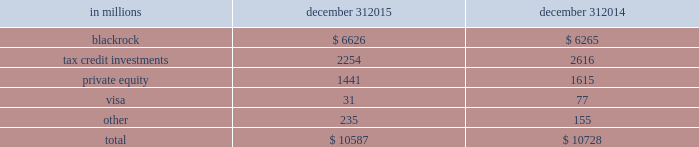An institution rated single-a by the credit rating agencies .
Given the illiquid nature of many of these types of investments , it can be a challenge to determine their fair values .
See note 7 fair value in the notes to consolidated financial statements in item 8 of this report for additional information .
Various pnc business units manage our equity and other investment activities .
Our businesses are responsible for making investment decisions within the approved policy limits and associated guidelines .
A summary of our equity investments follows : table 48 : equity investments summary in millions december 31 december 31 .
Blackrock pnc owned approximately 35 million common stock equivalent shares of blackrock equity at december 31 , 2015 , accounted for under the equity method .
The primary risk measurement , similar to other equity investments , is economic capital .
The business segments review section of this item 7 includes additional information about blackrock .
Tax credit investments included in our equity investments are direct tax credit investments and equity investments held by consolidated partnerships which totaled $ 2.3 billion at december 31 , 2015 and $ 2.6 billion at december 31 , 2014 .
These equity investment balances include unfunded commitments totaling $ 669 million and $ 717 million at december 31 , 2015 and december 31 , 2014 , respectively .
These unfunded commitments are included in other liabilities on our consolidated balance sheet .
Note 2 loan sale and servicing activities and variable interest entities in the notes to consolidated financial statements in item 8 of this report has further information on tax credit investments .
Private equity the private equity portfolio is an illiquid portfolio comprised of mezzanine and equity investments that vary by industry , stage and type of investment .
Private equity investments carried at estimated fair value totaled $ 1.4 billion at december 31 , 2015 and $ 1.6 billion at december 31 , 2014 .
As of december 31 , 2015 , $ 1.1 billion was invested directly in a variety of companies and $ .3 billion was invested indirectly through various private equity funds .
Included in direct investments are investment activities of two private equity funds that are consolidated for financial reporting purposes .
The noncontrolling interests of these funds totaled $ 170 million as of december 31 , 2015 .
The interests held in indirect private equity funds are not redeemable , but pnc may receive distributions over the life of the partnership from liquidation of the underlying investments .
See item 1 business 2013 supervision and regulation and item 1a risk factors of this report for discussion of the potential impacts of the volcker rule provisions of dodd-frank on our interests in and of private funds covered by the volcker rule .
In 2015 , pnc invested with six other banks in early warning services ( ews ) , a provider of fraud prevention and risk management solutions .
Ews then acquired clearxchange , a network through which customers send and receive person-to- person payments .
Integrating these businesses will enable us to , among other things , create a secure , real-time payments network .
Our unfunded commitments related to private equity totaled $ 126 million at december 31 , 2015 compared with $ 140 million at december 31 , 2014 .
See note 7 fair value , note 20 legal proceedings and note 21 commitments and guarantees in the notes to consolidated financial statements in item 8 of this report for additional information regarding the october 2007 visa restructuring , our involvement with judgment and loss sharing agreements with visa and certain other banks , the status of pending interchange litigation , the sales of portions of our visa class b common shares and the related swap agreements with the purchasers .
During 2015 , we sold 2.0 million visa class b common shares , in addition to the 16.5 million shares sold in previous years .
We have entered into swap agreements with the purchasers of the shares as part of these sales .
See note 7 fair value in the notes to consolidated financial statements in item 8 of this report for additional information .
At december 31 , 2015 , our investment in visa class b common shares totaled approximately 4.9 million shares and had a carrying value of $ 31 million .
Based on the december 31 , 2015 closing price of $ 77.55 for the visa class a common shares , the fair value of our total investment was approximately $ 622 million at the current conversion rate .
The visa class b common shares that we own are transferable only under limited circumstances until they can be converted into shares of the publicly traded class of stock , which cannot happen until the settlement of all of the specified litigation .
90 the pnc financial services group , inc .
2013 form 10-k .
What was the change in private equity investments carried at estimated fair value between december 31 , 2015 and december 31 , 2014 , in billions? 
Computations: (1.6 - 1.4)
Answer: 0.2. 